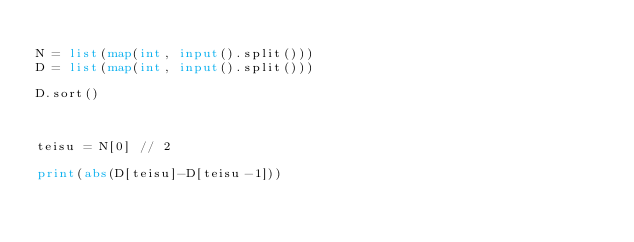<code> <loc_0><loc_0><loc_500><loc_500><_Python_>
N = list(map(int, input().split()))
D = list(map(int, input().split()))

D.sort()



teisu = N[0] // 2

print(abs(D[teisu]-D[teisu-1]))</code> 